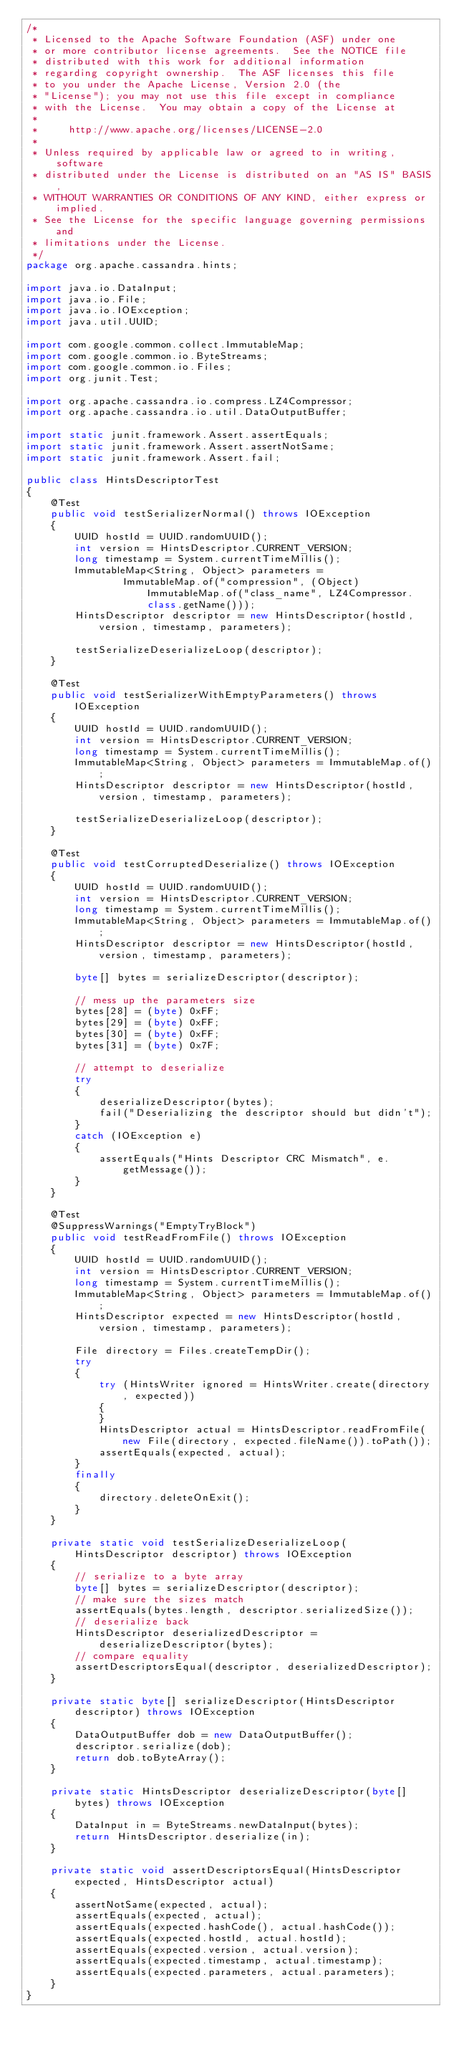<code> <loc_0><loc_0><loc_500><loc_500><_Java_>/*
 * Licensed to the Apache Software Foundation (ASF) under one
 * or more contributor license agreements.  See the NOTICE file
 * distributed with this work for additional information
 * regarding copyright ownership.  The ASF licenses this file
 * to you under the Apache License, Version 2.0 (the
 * "License"); you may not use this file except in compliance
 * with the License.  You may obtain a copy of the License at
 *
 *     http://www.apache.org/licenses/LICENSE-2.0
 *
 * Unless required by applicable law or agreed to in writing, software
 * distributed under the License is distributed on an "AS IS" BASIS,
 * WITHOUT WARRANTIES OR CONDITIONS OF ANY KIND, either express or implied.
 * See the License for the specific language governing permissions and
 * limitations under the License.
 */
package org.apache.cassandra.hints;

import java.io.DataInput;
import java.io.File;
import java.io.IOException;
import java.util.UUID;

import com.google.common.collect.ImmutableMap;
import com.google.common.io.ByteStreams;
import com.google.common.io.Files;
import org.junit.Test;

import org.apache.cassandra.io.compress.LZ4Compressor;
import org.apache.cassandra.io.util.DataOutputBuffer;

import static junit.framework.Assert.assertEquals;
import static junit.framework.Assert.assertNotSame;
import static junit.framework.Assert.fail;

public class HintsDescriptorTest
{
    @Test
    public void testSerializerNormal() throws IOException
    {
        UUID hostId = UUID.randomUUID();
        int version = HintsDescriptor.CURRENT_VERSION;
        long timestamp = System.currentTimeMillis();
        ImmutableMap<String, Object> parameters =
                ImmutableMap.of("compression", (Object) ImmutableMap.of("class_name", LZ4Compressor.class.getName()));
        HintsDescriptor descriptor = new HintsDescriptor(hostId, version, timestamp, parameters);

        testSerializeDeserializeLoop(descriptor);
    }

    @Test
    public void testSerializerWithEmptyParameters() throws IOException
    {
        UUID hostId = UUID.randomUUID();
        int version = HintsDescriptor.CURRENT_VERSION;
        long timestamp = System.currentTimeMillis();
        ImmutableMap<String, Object> parameters = ImmutableMap.of();
        HintsDescriptor descriptor = new HintsDescriptor(hostId, version, timestamp, parameters);

        testSerializeDeserializeLoop(descriptor);
    }

    @Test
    public void testCorruptedDeserialize() throws IOException
    {
        UUID hostId = UUID.randomUUID();
        int version = HintsDescriptor.CURRENT_VERSION;
        long timestamp = System.currentTimeMillis();
        ImmutableMap<String, Object> parameters = ImmutableMap.of();
        HintsDescriptor descriptor = new HintsDescriptor(hostId, version, timestamp, parameters);

        byte[] bytes = serializeDescriptor(descriptor);

        // mess up the parameters size
        bytes[28] = (byte) 0xFF;
        bytes[29] = (byte) 0xFF;
        bytes[30] = (byte) 0xFF;
        bytes[31] = (byte) 0x7F;

        // attempt to deserialize
        try
        {
            deserializeDescriptor(bytes);
            fail("Deserializing the descriptor should but didn't");
        }
        catch (IOException e)
        {
            assertEquals("Hints Descriptor CRC Mismatch", e.getMessage());
        }
    }

    @Test
    @SuppressWarnings("EmptyTryBlock")
    public void testReadFromFile() throws IOException
    {
        UUID hostId = UUID.randomUUID();
        int version = HintsDescriptor.CURRENT_VERSION;
        long timestamp = System.currentTimeMillis();
        ImmutableMap<String, Object> parameters = ImmutableMap.of();
        HintsDescriptor expected = new HintsDescriptor(hostId, version, timestamp, parameters);

        File directory = Files.createTempDir();
        try
        {
            try (HintsWriter ignored = HintsWriter.create(directory, expected))
            {
            }
            HintsDescriptor actual = HintsDescriptor.readFromFile(new File(directory, expected.fileName()).toPath());
            assertEquals(expected, actual);
        }
        finally
        {
            directory.deleteOnExit();
        }
    }

    private static void testSerializeDeserializeLoop(HintsDescriptor descriptor) throws IOException
    {
        // serialize to a byte array
        byte[] bytes = serializeDescriptor(descriptor);
        // make sure the sizes match
        assertEquals(bytes.length, descriptor.serializedSize());
        // deserialize back
        HintsDescriptor deserializedDescriptor = deserializeDescriptor(bytes);
        // compare equality
        assertDescriptorsEqual(descriptor, deserializedDescriptor);
    }

    private static byte[] serializeDescriptor(HintsDescriptor descriptor) throws IOException
    {
        DataOutputBuffer dob = new DataOutputBuffer();
        descriptor.serialize(dob);
        return dob.toByteArray();
    }

    private static HintsDescriptor deserializeDescriptor(byte[] bytes) throws IOException
    {
        DataInput in = ByteStreams.newDataInput(bytes);
        return HintsDescriptor.deserialize(in);
    }

    private static void assertDescriptorsEqual(HintsDescriptor expected, HintsDescriptor actual)
    {
        assertNotSame(expected, actual);
        assertEquals(expected, actual);
        assertEquals(expected.hashCode(), actual.hashCode());
        assertEquals(expected.hostId, actual.hostId);
        assertEquals(expected.version, actual.version);
        assertEquals(expected.timestamp, actual.timestamp);
        assertEquals(expected.parameters, actual.parameters);
    }
}
</code> 